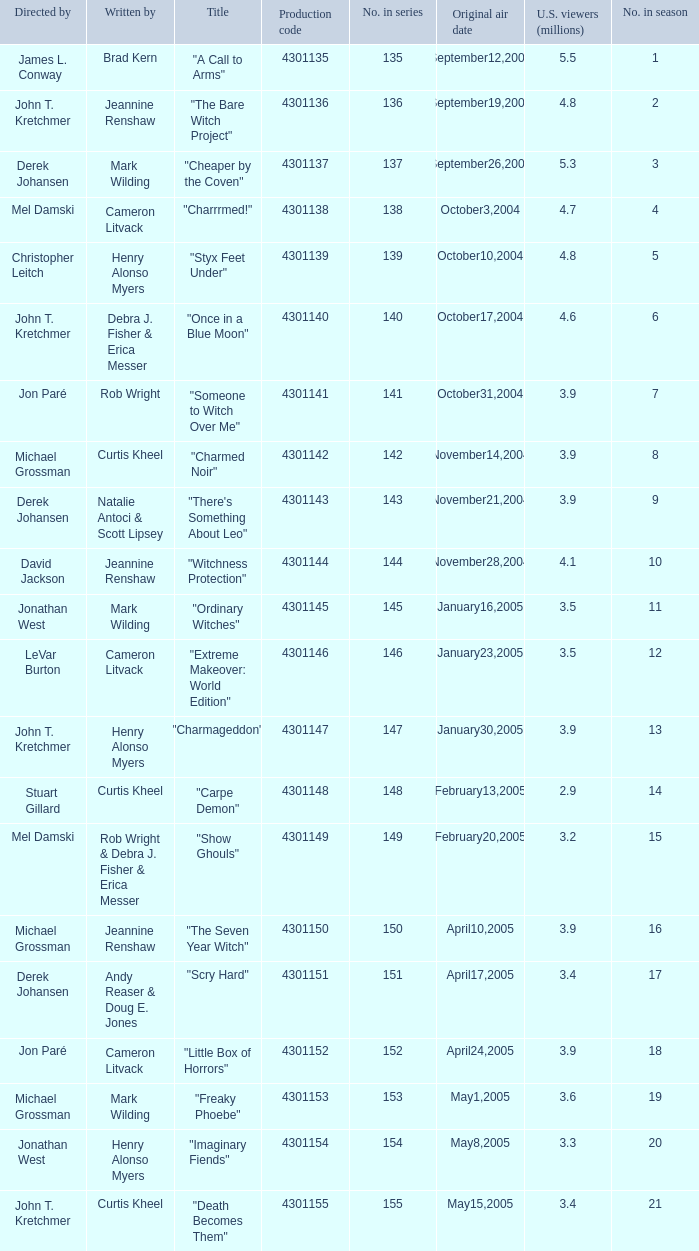In season number 3,  who were the writers? Mark Wilding. 